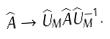Convert formula to latex. <formula><loc_0><loc_0><loc_500><loc_500>\widehat { A } \rightarrow \widehat { U } _ { M } \widehat { A } \widehat { U } _ { M } ^ { - 1 } .</formula> 